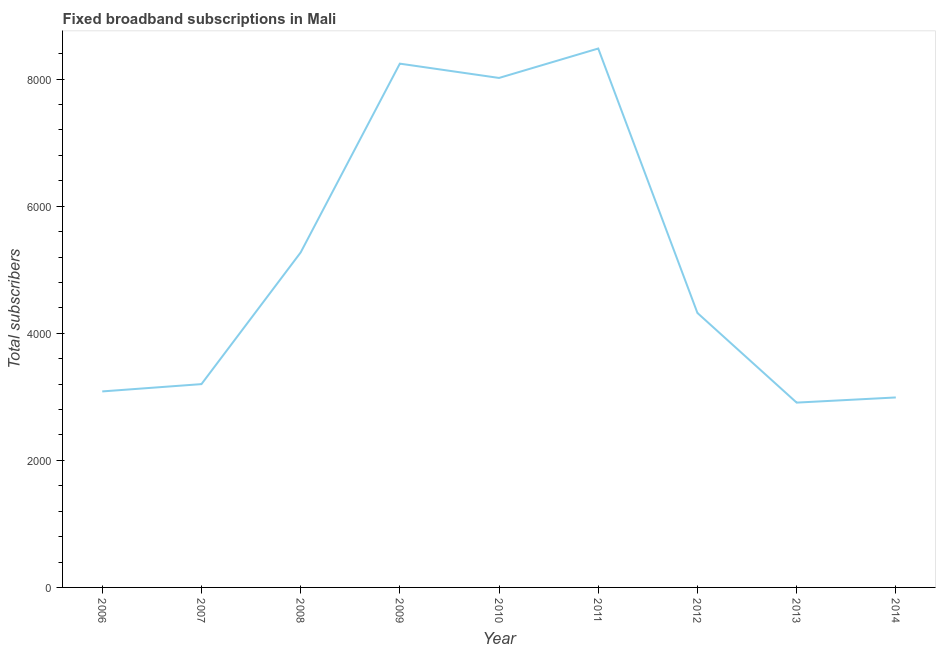What is the total number of fixed broadband subscriptions in 2008?
Your answer should be very brief. 5272. Across all years, what is the maximum total number of fixed broadband subscriptions?
Offer a very short reply. 8482. Across all years, what is the minimum total number of fixed broadband subscriptions?
Offer a terse response. 2909. In which year was the total number of fixed broadband subscriptions maximum?
Your answer should be compact. 2011. What is the sum of the total number of fixed broadband subscriptions?
Provide a succinct answer. 4.65e+04. What is the difference between the total number of fixed broadband subscriptions in 2007 and 2014?
Offer a very short reply. 210. What is the average total number of fixed broadband subscriptions per year?
Keep it short and to the point. 5169. What is the median total number of fixed broadband subscriptions?
Your response must be concise. 4320. In how many years, is the total number of fixed broadband subscriptions greater than 1600 ?
Keep it short and to the point. 9. Do a majority of the years between 2010 and 2007 (inclusive) have total number of fixed broadband subscriptions greater than 800 ?
Your answer should be compact. Yes. What is the ratio of the total number of fixed broadband subscriptions in 2006 to that in 2009?
Your response must be concise. 0.37. Is the total number of fixed broadband subscriptions in 2007 less than that in 2010?
Offer a terse response. Yes. What is the difference between the highest and the second highest total number of fixed broadband subscriptions?
Your answer should be very brief. 238. What is the difference between the highest and the lowest total number of fixed broadband subscriptions?
Offer a terse response. 5573. Does the total number of fixed broadband subscriptions monotonically increase over the years?
Provide a short and direct response. No. Are the values on the major ticks of Y-axis written in scientific E-notation?
Offer a terse response. No. Does the graph contain any zero values?
Keep it short and to the point. No. What is the title of the graph?
Give a very brief answer. Fixed broadband subscriptions in Mali. What is the label or title of the Y-axis?
Provide a succinct answer. Total subscribers. What is the Total subscribers in 2006?
Provide a succinct answer. 3085. What is the Total subscribers of 2007?
Make the answer very short. 3200. What is the Total subscribers of 2008?
Keep it short and to the point. 5272. What is the Total subscribers of 2009?
Ensure brevity in your answer.  8244. What is the Total subscribers of 2010?
Offer a very short reply. 8019. What is the Total subscribers in 2011?
Your response must be concise. 8482. What is the Total subscribers in 2012?
Your response must be concise. 4320. What is the Total subscribers in 2013?
Your answer should be compact. 2909. What is the Total subscribers of 2014?
Provide a succinct answer. 2990. What is the difference between the Total subscribers in 2006 and 2007?
Make the answer very short. -115. What is the difference between the Total subscribers in 2006 and 2008?
Give a very brief answer. -2187. What is the difference between the Total subscribers in 2006 and 2009?
Give a very brief answer. -5159. What is the difference between the Total subscribers in 2006 and 2010?
Provide a short and direct response. -4934. What is the difference between the Total subscribers in 2006 and 2011?
Offer a very short reply. -5397. What is the difference between the Total subscribers in 2006 and 2012?
Offer a terse response. -1235. What is the difference between the Total subscribers in 2006 and 2013?
Offer a very short reply. 176. What is the difference between the Total subscribers in 2007 and 2008?
Offer a terse response. -2072. What is the difference between the Total subscribers in 2007 and 2009?
Give a very brief answer. -5044. What is the difference between the Total subscribers in 2007 and 2010?
Your answer should be compact. -4819. What is the difference between the Total subscribers in 2007 and 2011?
Provide a short and direct response. -5282. What is the difference between the Total subscribers in 2007 and 2012?
Give a very brief answer. -1120. What is the difference between the Total subscribers in 2007 and 2013?
Provide a succinct answer. 291. What is the difference between the Total subscribers in 2007 and 2014?
Offer a terse response. 210. What is the difference between the Total subscribers in 2008 and 2009?
Give a very brief answer. -2972. What is the difference between the Total subscribers in 2008 and 2010?
Keep it short and to the point. -2747. What is the difference between the Total subscribers in 2008 and 2011?
Make the answer very short. -3210. What is the difference between the Total subscribers in 2008 and 2012?
Offer a terse response. 952. What is the difference between the Total subscribers in 2008 and 2013?
Make the answer very short. 2363. What is the difference between the Total subscribers in 2008 and 2014?
Offer a terse response. 2282. What is the difference between the Total subscribers in 2009 and 2010?
Give a very brief answer. 225. What is the difference between the Total subscribers in 2009 and 2011?
Your answer should be compact. -238. What is the difference between the Total subscribers in 2009 and 2012?
Ensure brevity in your answer.  3924. What is the difference between the Total subscribers in 2009 and 2013?
Your response must be concise. 5335. What is the difference between the Total subscribers in 2009 and 2014?
Provide a succinct answer. 5254. What is the difference between the Total subscribers in 2010 and 2011?
Offer a very short reply. -463. What is the difference between the Total subscribers in 2010 and 2012?
Your response must be concise. 3699. What is the difference between the Total subscribers in 2010 and 2013?
Your answer should be very brief. 5110. What is the difference between the Total subscribers in 2010 and 2014?
Your answer should be very brief. 5029. What is the difference between the Total subscribers in 2011 and 2012?
Ensure brevity in your answer.  4162. What is the difference between the Total subscribers in 2011 and 2013?
Offer a terse response. 5573. What is the difference between the Total subscribers in 2011 and 2014?
Offer a very short reply. 5492. What is the difference between the Total subscribers in 2012 and 2013?
Offer a terse response. 1411. What is the difference between the Total subscribers in 2012 and 2014?
Provide a succinct answer. 1330. What is the difference between the Total subscribers in 2013 and 2014?
Give a very brief answer. -81. What is the ratio of the Total subscribers in 2006 to that in 2007?
Offer a terse response. 0.96. What is the ratio of the Total subscribers in 2006 to that in 2008?
Your response must be concise. 0.58. What is the ratio of the Total subscribers in 2006 to that in 2009?
Provide a succinct answer. 0.37. What is the ratio of the Total subscribers in 2006 to that in 2010?
Your response must be concise. 0.39. What is the ratio of the Total subscribers in 2006 to that in 2011?
Ensure brevity in your answer.  0.36. What is the ratio of the Total subscribers in 2006 to that in 2012?
Your response must be concise. 0.71. What is the ratio of the Total subscribers in 2006 to that in 2013?
Provide a short and direct response. 1.06. What is the ratio of the Total subscribers in 2006 to that in 2014?
Ensure brevity in your answer.  1.03. What is the ratio of the Total subscribers in 2007 to that in 2008?
Give a very brief answer. 0.61. What is the ratio of the Total subscribers in 2007 to that in 2009?
Give a very brief answer. 0.39. What is the ratio of the Total subscribers in 2007 to that in 2010?
Offer a terse response. 0.4. What is the ratio of the Total subscribers in 2007 to that in 2011?
Your answer should be very brief. 0.38. What is the ratio of the Total subscribers in 2007 to that in 2012?
Provide a short and direct response. 0.74. What is the ratio of the Total subscribers in 2007 to that in 2013?
Keep it short and to the point. 1.1. What is the ratio of the Total subscribers in 2007 to that in 2014?
Your response must be concise. 1.07. What is the ratio of the Total subscribers in 2008 to that in 2009?
Offer a terse response. 0.64. What is the ratio of the Total subscribers in 2008 to that in 2010?
Your response must be concise. 0.66. What is the ratio of the Total subscribers in 2008 to that in 2011?
Provide a succinct answer. 0.62. What is the ratio of the Total subscribers in 2008 to that in 2012?
Give a very brief answer. 1.22. What is the ratio of the Total subscribers in 2008 to that in 2013?
Keep it short and to the point. 1.81. What is the ratio of the Total subscribers in 2008 to that in 2014?
Offer a very short reply. 1.76. What is the ratio of the Total subscribers in 2009 to that in 2010?
Make the answer very short. 1.03. What is the ratio of the Total subscribers in 2009 to that in 2012?
Make the answer very short. 1.91. What is the ratio of the Total subscribers in 2009 to that in 2013?
Your response must be concise. 2.83. What is the ratio of the Total subscribers in 2009 to that in 2014?
Keep it short and to the point. 2.76. What is the ratio of the Total subscribers in 2010 to that in 2011?
Your answer should be very brief. 0.94. What is the ratio of the Total subscribers in 2010 to that in 2012?
Your response must be concise. 1.86. What is the ratio of the Total subscribers in 2010 to that in 2013?
Give a very brief answer. 2.76. What is the ratio of the Total subscribers in 2010 to that in 2014?
Your answer should be compact. 2.68. What is the ratio of the Total subscribers in 2011 to that in 2012?
Keep it short and to the point. 1.96. What is the ratio of the Total subscribers in 2011 to that in 2013?
Give a very brief answer. 2.92. What is the ratio of the Total subscribers in 2011 to that in 2014?
Ensure brevity in your answer.  2.84. What is the ratio of the Total subscribers in 2012 to that in 2013?
Provide a short and direct response. 1.49. What is the ratio of the Total subscribers in 2012 to that in 2014?
Ensure brevity in your answer.  1.45. 